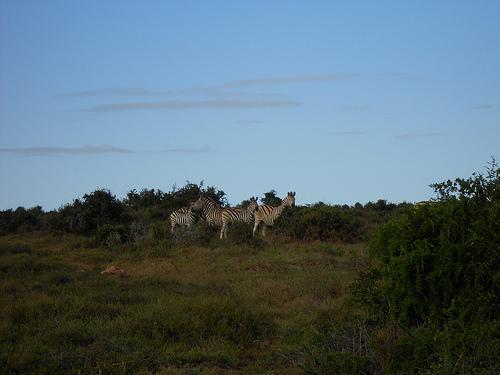Question: where is this scene occurring?
Choices:
A. On the mountaintop.
B. In the desert.
C. In the river.
D. On a hillside.
Answer with the letter. Answer: D Question: when is this scene taking place?
Choices:
A. Noon.
B. Midnight.
C. Dusk.
D. Morning.
Answer with the letter. Answer: C Question: what animal can be seen in the photo?
Choices:
A. Cheetah.
B. Antelope.
C. Zebra.
D. Gazelle.
Answer with the letter. Answer: C Question: how many zebras can be seen?
Choices:
A. 3.
B. 2.
C. 1.
D. 4.
Answer with the letter. Answer: D Question: who can be seen in this picture?
Choices:
A. The park ranger.
B. The zookeeper.
C. The clown.
D. No one.
Answer with the letter. Answer: D Question: what are the zebras doing?
Choices:
A. Stampeding.
B. Grazing.
C. Migrating.
D. Staring into the distance.
Answer with the letter. Answer: D 